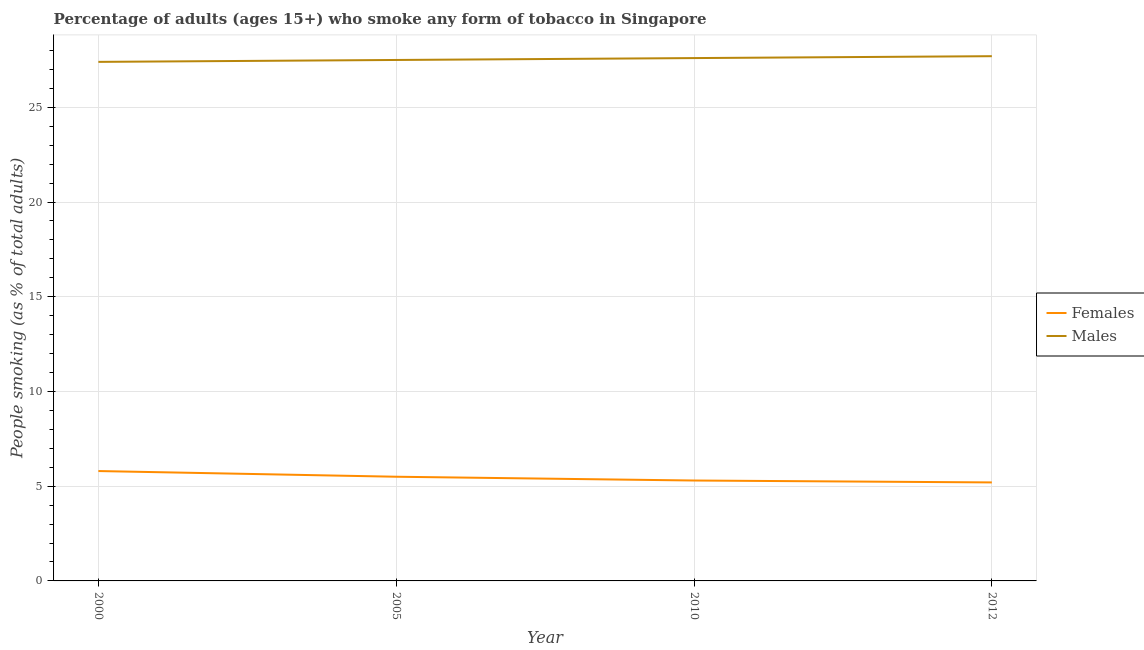Is the number of lines equal to the number of legend labels?
Give a very brief answer. Yes. What is the percentage of males who smoke in 2012?
Your answer should be compact. 27.7. Across all years, what is the maximum percentage of males who smoke?
Offer a very short reply. 27.7. In which year was the percentage of females who smoke maximum?
Offer a terse response. 2000. In which year was the percentage of females who smoke minimum?
Your answer should be compact. 2012. What is the total percentage of males who smoke in the graph?
Offer a terse response. 110.2. What is the difference between the percentage of males who smoke in 2000 and that in 2012?
Keep it short and to the point. -0.3. What is the difference between the percentage of males who smoke in 2012 and the percentage of females who smoke in 2010?
Your response must be concise. 22.4. What is the average percentage of females who smoke per year?
Keep it short and to the point. 5.45. In the year 2010, what is the difference between the percentage of males who smoke and percentage of females who smoke?
Provide a short and direct response. 22.3. In how many years, is the percentage of males who smoke greater than 23 %?
Give a very brief answer. 4. What is the ratio of the percentage of females who smoke in 2000 to that in 2010?
Provide a succinct answer. 1.09. What is the difference between the highest and the second highest percentage of males who smoke?
Offer a terse response. 0.1. What is the difference between the highest and the lowest percentage of males who smoke?
Your response must be concise. 0.3. How many lines are there?
Provide a succinct answer. 2. How many years are there in the graph?
Make the answer very short. 4. Are the values on the major ticks of Y-axis written in scientific E-notation?
Your answer should be very brief. No. Does the graph contain grids?
Give a very brief answer. Yes. How many legend labels are there?
Ensure brevity in your answer.  2. How are the legend labels stacked?
Your answer should be compact. Vertical. What is the title of the graph?
Your answer should be very brief. Percentage of adults (ages 15+) who smoke any form of tobacco in Singapore. What is the label or title of the Y-axis?
Your response must be concise. People smoking (as % of total adults). What is the People smoking (as % of total adults) in Females in 2000?
Give a very brief answer. 5.8. What is the People smoking (as % of total adults) in Males in 2000?
Provide a succinct answer. 27.4. What is the People smoking (as % of total adults) of Females in 2005?
Keep it short and to the point. 5.5. What is the People smoking (as % of total adults) in Males in 2005?
Your answer should be very brief. 27.5. What is the People smoking (as % of total adults) in Females in 2010?
Offer a terse response. 5.3. What is the People smoking (as % of total adults) of Males in 2010?
Your answer should be compact. 27.6. What is the People smoking (as % of total adults) in Males in 2012?
Make the answer very short. 27.7. Across all years, what is the maximum People smoking (as % of total adults) in Males?
Provide a short and direct response. 27.7. Across all years, what is the minimum People smoking (as % of total adults) of Males?
Your answer should be very brief. 27.4. What is the total People smoking (as % of total adults) in Females in the graph?
Offer a very short reply. 21.8. What is the total People smoking (as % of total adults) of Males in the graph?
Your response must be concise. 110.2. What is the difference between the People smoking (as % of total adults) in Females in 2000 and that in 2005?
Ensure brevity in your answer.  0.3. What is the difference between the People smoking (as % of total adults) of Males in 2000 and that in 2005?
Keep it short and to the point. -0.1. What is the difference between the People smoking (as % of total adults) in Males in 2000 and that in 2012?
Provide a succinct answer. -0.3. What is the difference between the People smoking (as % of total adults) of Females in 2005 and that in 2010?
Give a very brief answer. 0.2. What is the difference between the People smoking (as % of total adults) in Males in 2005 and that in 2010?
Ensure brevity in your answer.  -0.1. What is the difference between the People smoking (as % of total adults) of Females in 2005 and that in 2012?
Ensure brevity in your answer.  0.3. What is the difference between the People smoking (as % of total adults) in Males in 2005 and that in 2012?
Provide a short and direct response. -0.2. What is the difference between the People smoking (as % of total adults) in Males in 2010 and that in 2012?
Provide a succinct answer. -0.1. What is the difference between the People smoking (as % of total adults) in Females in 2000 and the People smoking (as % of total adults) in Males in 2005?
Keep it short and to the point. -21.7. What is the difference between the People smoking (as % of total adults) of Females in 2000 and the People smoking (as % of total adults) of Males in 2010?
Ensure brevity in your answer.  -21.8. What is the difference between the People smoking (as % of total adults) in Females in 2000 and the People smoking (as % of total adults) in Males in 2012?
Keep it short and to the point. -21.9. What is the difference between the People smoking (as % of total adults) of Females in 2005 and the People smoking (as % of total adults) of Males in 2010?
Provide a succinct answer. -22.1. What is the difference between the People smoking (as % of total adults) of Females in 2005 and the People smoking (as % of total adults) of Males in 2012?
Offer a terse response. -22.2. What is the difference between the People smoking (as % of total adults) in Females in 2010 and the People smoking (as % of total adults) in Males in 2012?
Ensure brevity in your answer.  -22.4. What is the average People smoking (as % of total adults) of Females per year?
Your response must be concise. 5.45. What is the average People smoking (as % of total adults) in Males per year?
Provide a short and direct response. 27.55. In the year 2000, what is the difference between the People smoking (as % of total adults) in Females and People smoking (as % of total adults) in Males?
Provide a short and direct response. -21.6. In the year 2005, what is the difference between the People smoking (as % of total adults) in Females and People smoking (as % of total adults) in Males?
Provide a succinct answer. -22. In the year 2010, what is the difference between the People smoking (as % of total adults) in Females and People smoking (as % of total adults) in Males?
Ensure brevity in your answer.  -22.3. In the year 2012, what is the difference between the People smoking (as % of total adults) of Females and People smoking (as % of total adults) of Males?
Keep it short and to the point. -22.5. What is the ratio of the People smoking (as % of total adults) of Females in 2000 to that in 2005?
Provide a succinct answer. 1.05. What is the ratio of the People smoking (as % of total adults) in Females in 2000 to that in 2010?
Offer a terse response. 1.09. What is the ratio of the People smoking (as % of total adults) of Males in 2000 to that in 2010?
Your response must be concise. 0.99. What is the ratio of the People smoking (as % of total adults) in Females in 2000 to that in 2012?
Make the answer very short. 1.12. What is the ratio of the People smoking (as % of total adults) of Females in 2005 to that in 2010?
Your answer should be very brief. 1.04. What is the ratio of the People smoking (as % of total adults) of Females in 2005 to that in 2012?
Your answer should be compact. 1.06. What is the ratio of the People smoking (as % of total adults) of Males in 2005 to that in 2012?
Your answer should be very brief. 0.99. What is the ratio of the People smoking (as % of total adults) in Females in 2010 to that in 2012?
Keep it short and to the point. 1.02. What is the ratio of the People smoking (as % of total adults) of Males in 2010 to that in 2012?
Make the answer very short. 1. What is the difference between the highest and the second highest People smoking (as % of total adults) in Females?
Provide a succinct answer. 0.3. What is the difference between the highest and the second highest People smoking (as % of total adults) of Males?
Provide a short and direct response. 0.1. What is the difference between the highest and the lowest People smoking (as % of total adults) of Females?
Give a very brief answer. 0.6. What is the difference between the highest and the lowest People smoking (as % of total adults) of Males?
Keep it short and to the point. 0.3. 